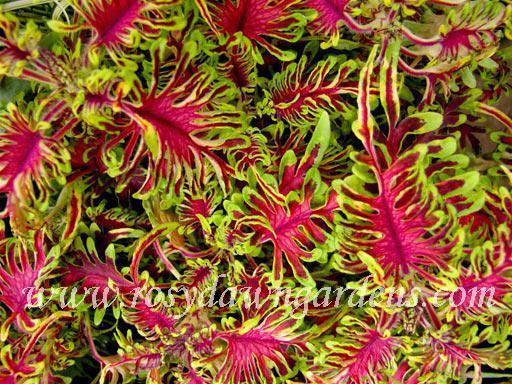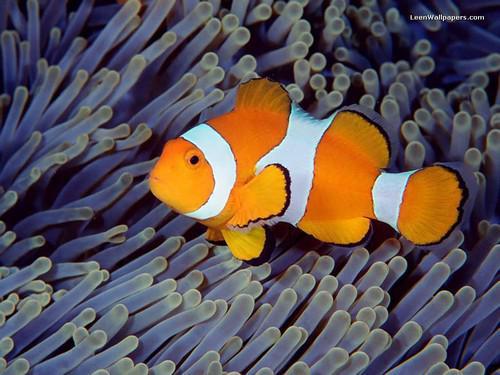The first image is the image on the left, the second image is the image on the right. Analyze the images presented: Is the assertion "There is a clownfish somewhere in the pair." valid? Answer yes or no. Yes. 